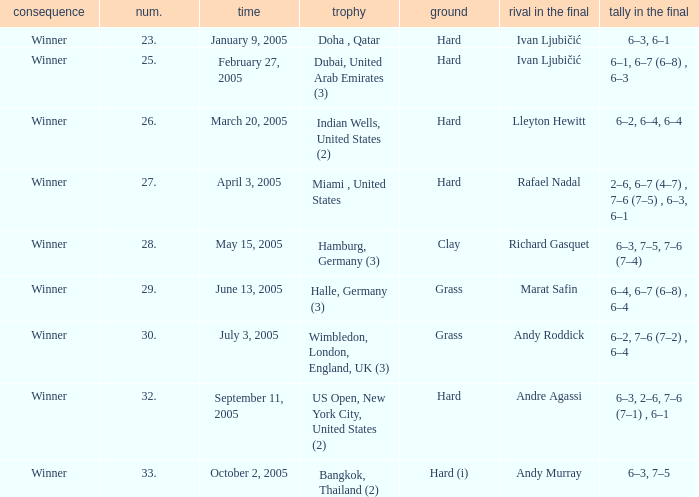In the championship Miami , United States, what is the score in the final? 2–6, 6–7 (4–7) , 7–6 (7–5) , 6–3, 6–1. 